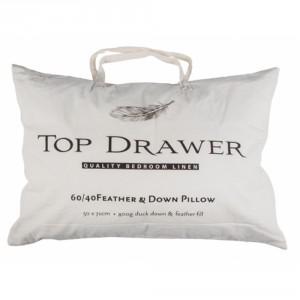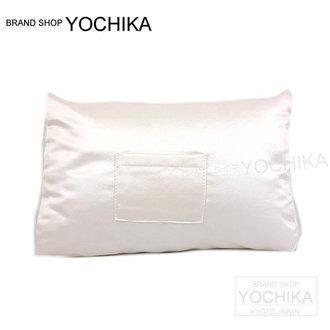The first image is the image on the left, the second image is the image on the right. Analyze the images presented: Is the assertion "The left and right image contains the same number of white pillows" valid? Answer yes or no. Yes. The first image is the image on the left, the second image is the image on the right. Given the left and right images, does the statement "The left image contains a handled pillow shape with black text printed on its front, and the right image features a pillow with no handle." hold true? Answer yes or no. Yes. 